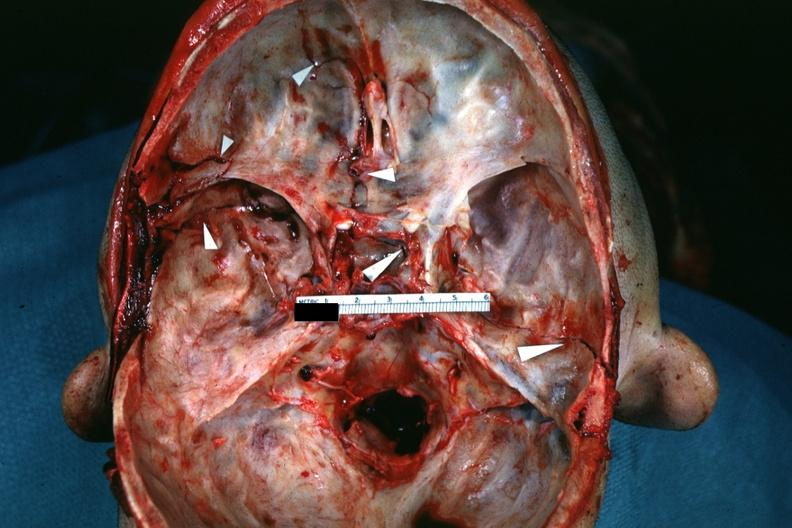s lateral view of head with ear lobe crease and web neck other photos in file slide?
Answer the question using a single word or phrase. No 